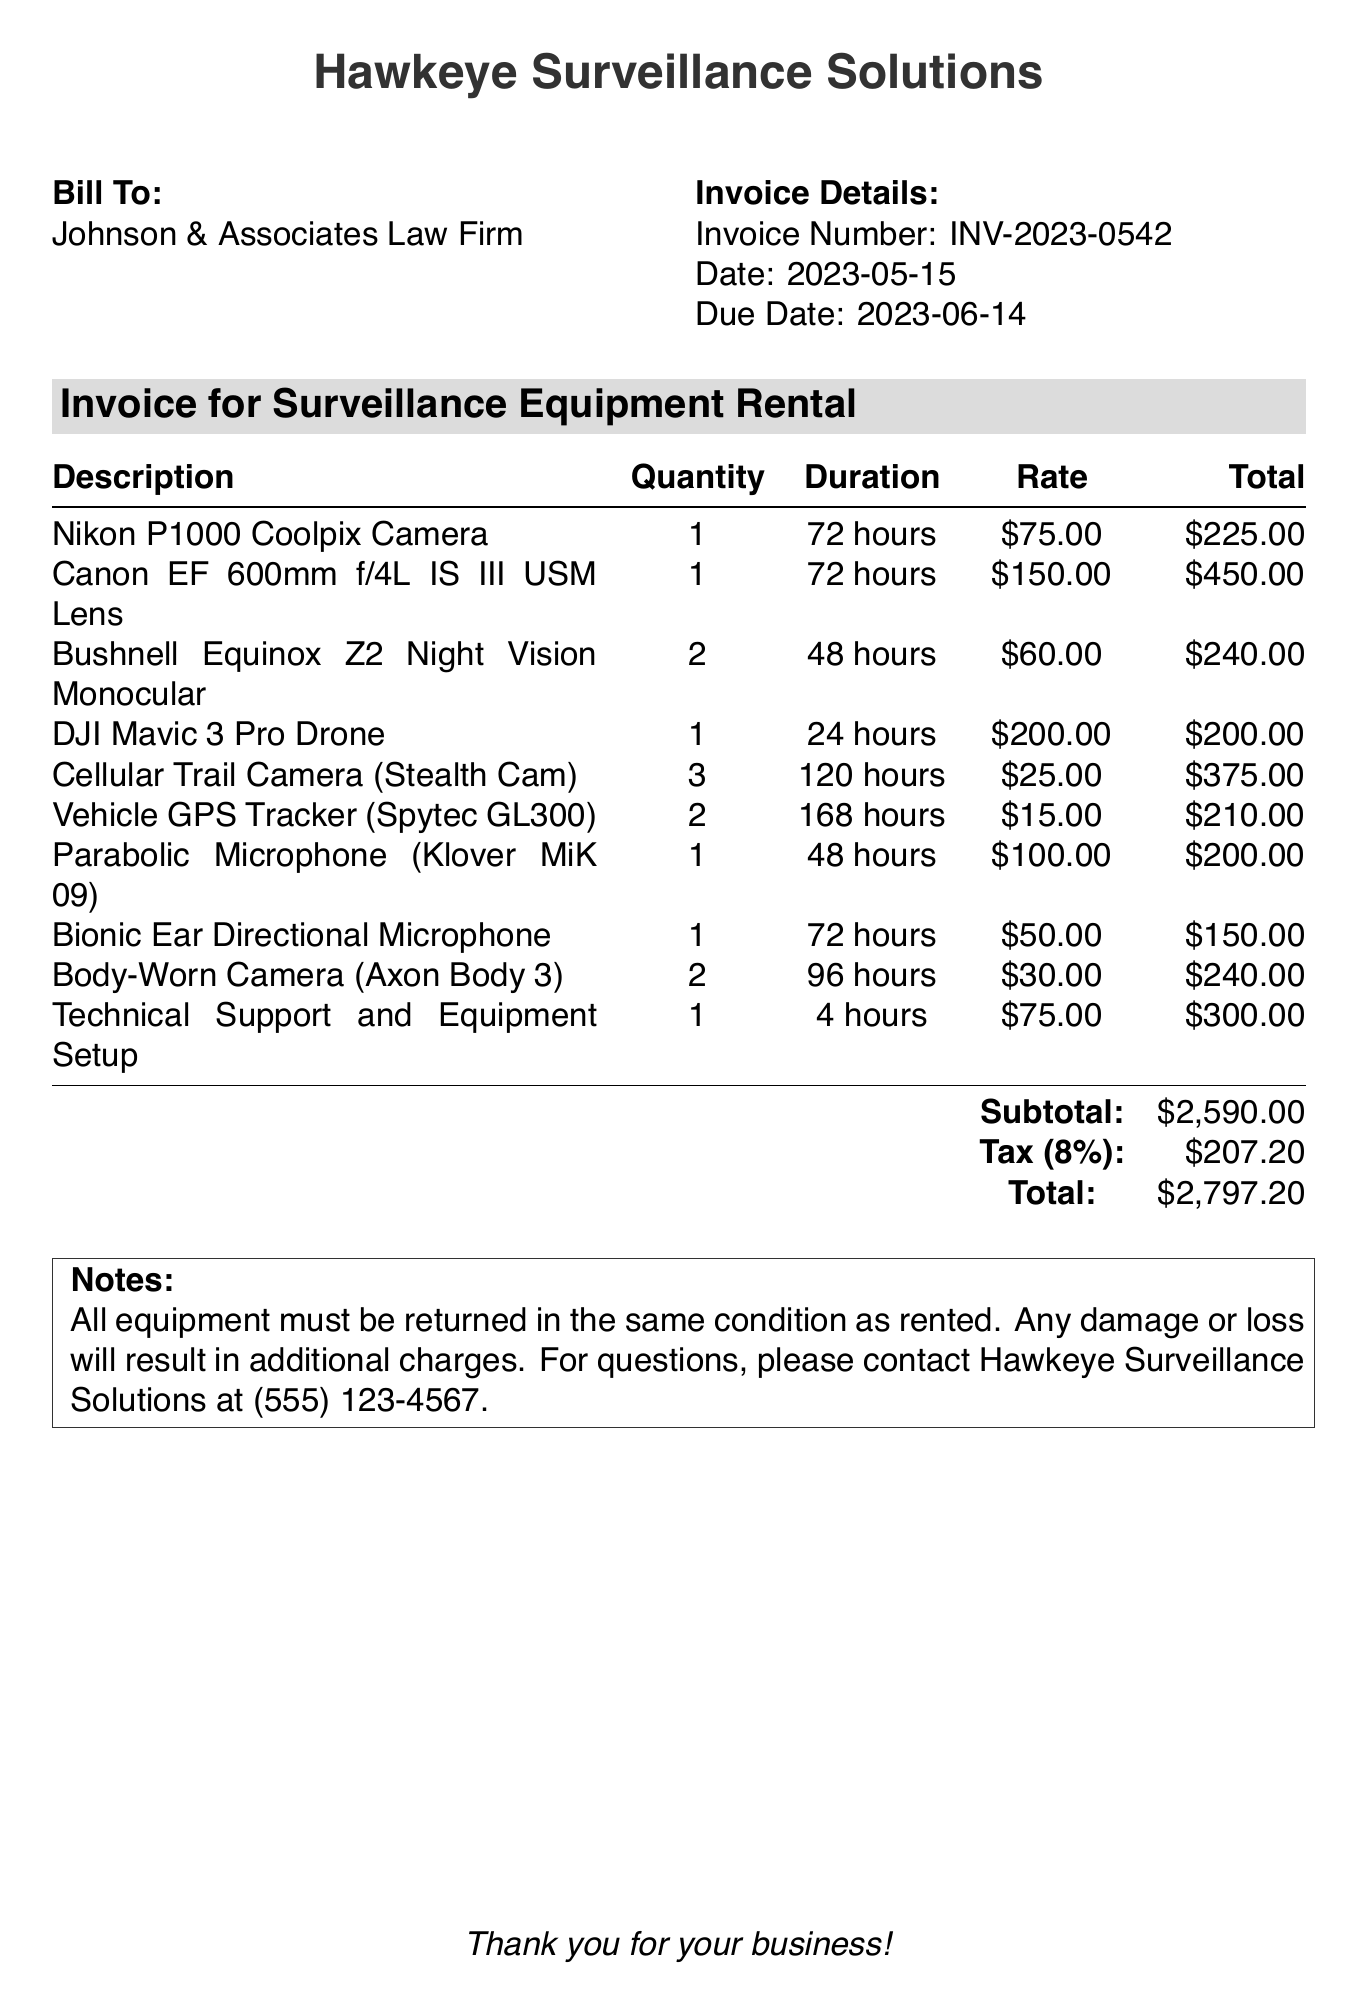What is the invoice number? The invoice number is a unique identifier for the billing document, specified as INV-2023-0542.
Answer: INV-2023-0542 Who is the client? The client is mentioned at the beginning of the document, which is Johnson & Associates Law Firm.
Answer: Johnson & Associates Law Firm What is the total amount due? The total amount due is listed in the summary of the invoice, which combines the subtotal and tax.
Answer: $2,797.20 How many hours was the Cellular Trail Camera rented for? The duration of the rental for the Cellular Trail Camera is specified in the itemized section of the invoice as 120 hours.
Answer: 120 hours What is the tax rate applied to the invoice? The tax rate is stated in the invoice as 8%, which is applied to the subtotal amount.
Answer: 8% How much was charged for the Vehicle GPS Tracker? The total amount charged for the Vehicle GPS Tracker is given in the itemized list as $210.00.
Answer: $210.00 What type of service is listed as the last item? The last item on the invoice discusses the service related to equipment and support.
Answer: Technical Support and Equipment Setup How many Body-Worn Cameras were rented? The rental quantity for Body-Worn Cameras is specified in the invoice, indicating that 2 cameras were rented.
Answer: 2 What is the due date for the invoice payment? The payment due date is mentioned clearly in the invoice details section as June 14, 2023.
Answer: June 14, 2023 